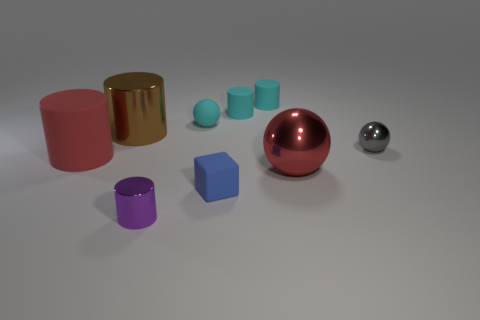There is a large shiny object that is right of the tiny blue object; is its shape the same as the gray thing?
Your response must be concise. Yes. There is a red thing that is the same shape as the big brown thing; what is its material?
Your response must be concise. Rubber. How many red objects are the same size as the blue object?
Your response must be concise. 0. There is a sphere that is both behind the big red metallic sphere and to the right of the tiny blue cube; what is its color?
Offer a terse response. Gray. Are there fewer big matte things than big red objects?
Provide a succinct answer. Yes. Does the big rubber object have the same color as the big thing that is to the right of the big shiny cylinder?
Keep it short and to the point. Yes. Are there the same number of metal things behind the gray shiny object and matte balls on the left side of the red matte cylinder?
Provide a succinct answer. No. How many big matte objects have the same shape as the small blue rubber thing?
Provide a short and direct response. 0. Are there any small cyan metallic objects?
Provide a succinct answer. No. Is the small purple cylinder made of the same material as the red thing that is on the left side of the blue matte cube?
Your answer should be very brief. No. 